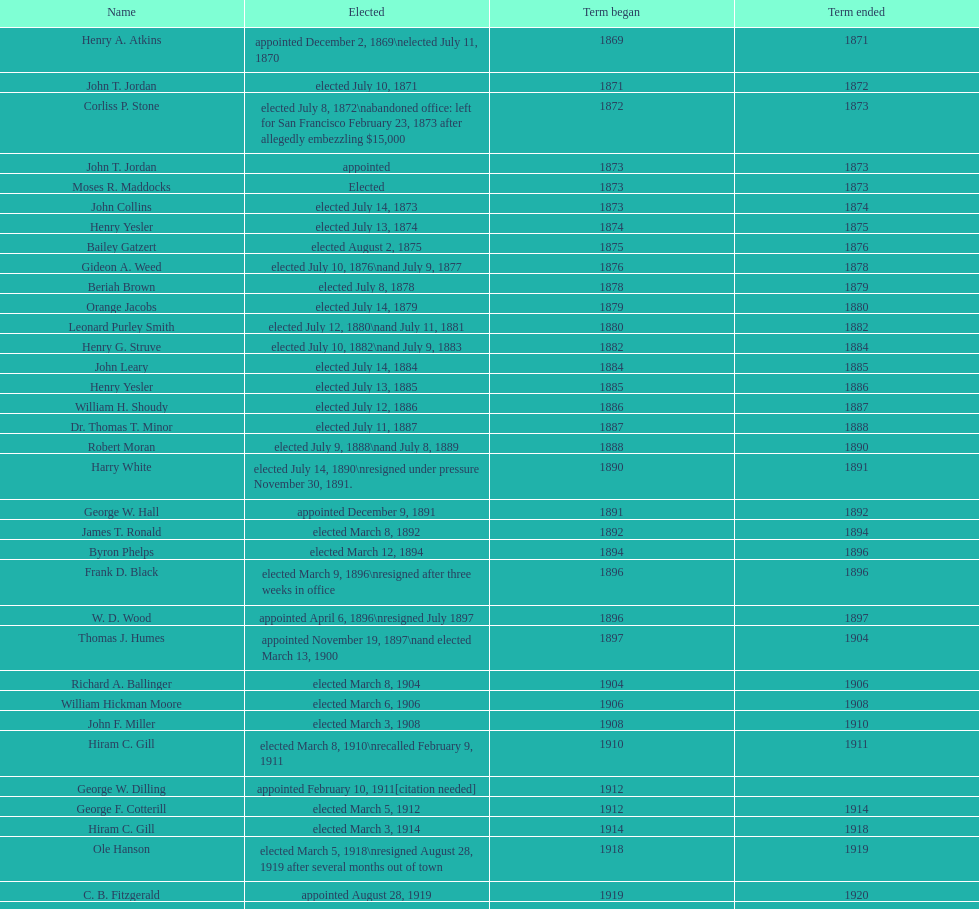Give me the full table as a dictionary. {'header': ['Name', 'Elected', 'Term began', 'Term ended'], 'rows': [['Henry A. Atkins', 'appointed December 2, 1869\\nelected July 11, 1870', '1869', '1871'], ['John T. Jordan', 'elected July 10, 1871', '1871', '1872'], ['Corliss P. Stone', 'elected July 8, 1872\\nabandoned office: left for San Francisco February 23, 1873 after allegedly embezzling $15,000', '1872', '1873'], ['John T. Jordan', 'appointed', '1873', '1873'], ['Moses R. Maddocks', 'Elected', '1873', '1873'], ['John Collins', 'elected July 14, 1873', '1873', '1874'], ['Henry Yesler', 'elected July 13, 1874', '1874', '1875'], ['Bailey Gatzert', 'elected August 2, 1875', '1875', '1876'], ['Gideon A. Weed', 'elected July 10, 1876\\nand July 9, 1877', '1876', '1878'], ['Beriah Brown', 'elected July 8, 1878', '1878', '1879'], ['Orange Jacobs', 'elected July 14, 1879', '1879', '1880'], ['Leonard Purley Smith', 'elected July 12, 1880\\nand July 11, 1881', '1880', '1882'], ['Henry G. Struve', 'elected July 10, 1882\\nand July 9, 1883', '1882', '1884'], ['John Leary', 'elected July 14, 1884', '1884', '1885'], ['Henry Yesler', 'elected July 13, 1885', '1885', '1886'], ['William H. Shoudy', 'elected July 12, 1886', '1886', '1887'], ['Dr. Thomas T. Minor', 'elected July 11, 1887', '1887', '1888'], ['Robert Moran', 'elected July 9, 1888\\nand July 8, 1889', '1888', '1890'], ['Harry White', 'elected July 14, 1890\\nresigned under pressure November 30, 1891.', '1890', '1891'], ['George W. Hall', 'appointed December 9, 1891', '1891', '1892'], ['James T. Ronald', 'elected March 8, 1892', '1892', '1894'], ['Byron Phelps', 'elected March 12, 1894', '1894', '1896'], ['Frank D. Black', 'elected March 9, 1896\\nresigned after three weeks in office', '1896', '1896'], ['W. D. Wood', 'appointed April 6, 1896\\nresigned July 1897', '1896', '1897'], ['Thomas J. Humes', 'appointed November 19, 1897\\nand elected March 13, 1900', '1897', '1904'], ['Richard A. Ballinger', 'elected March 8, 1904', '1904', '1906'], ['William Hickman Moore', 'elected March 6, 1906', '1906', '1908'], ['John F. Miller', 'elected March 3, 1908', '1908', '1910'], ['Hiram C. Gill', 'elected March 8, 1910\\nrecalled February 9, 1911', '1910', '1911'], ['George W. Dilling', 'appointed February 10, 1911[citation needed]', '1912', ''], ['George F. Cotterill', 'elected March 5, 1912', '1912', '1914'], ['Hiram C. Gill', 'elected March 3, 1914', '1914', '1918'], ['Ole Hanson', 'elected March 5, 1918\\nresigned August 28, 1919 after several months out of town', '1918', '1919'], ['C. B. Fitzgerald', 'appointed August 28, 1919', '1919', '1920'], ['Hugh M. Caldwell', 'elected March 2, 1920', '1920', '1922'], ['Edwin J. Brown', 'elected May 2, 1922\\nand March 4, 1924', '1922', '1926'], ['Bertha Knight Landes', 'elected March 9, 1926', '1926', '1928'], ['Frank E. Edwards', 'elected March 6, 1928\\nand March 4, 1930\\nrecalled July 13, 1931', '1928', '1931'], ['Robert H. Harlin', 'appointed July 14, 1931', '1931', '1932'], ['John F. Dore', 'elected March 8, 1932', '1932', '1934'], ['Charles L. Smith', 'elected March 6, 1934', '1934', '1936'], ['John F. Dore', 'elected March 3, 1936\\nbecame gravely ill and was relieved of office April 13, 1938, already a lame duck after the 1938 election. He died five days later.', '1936', '1938'], ['Arthur B. Langlie', "elected March 8, 1938\\nappointed to take office early, April 27, 1938, after Dore's death.\\nelected March 5, 1940\\nresigned January 11, 1941, to become Governor of Washington", '1938', '1941'], ['John E. Carroll', 'appointed January 27, 1941', '1941', '1941'], ['Earl Millikin', 'elected March 4, 1941', '1941', '1942'], ['William F. Devin', 'elected March 3, 1942, March 7, 1944, March 5, 1946, and March 2, 1948', '1942', '1952'], ['Allan Pomeroy', 'elected March 4, 1952', '1952', '1956'], ['Gordon S. Clinton', 'elected March 6, 1956\\nand March 8, 1960', '1956', '1964'], ["James d'Orma Braman", 'elected March 10, 1964\\nresigned March 23, 1969, to accept an appointment as an Assistant Secretary in the Department of Transportation in the Nixon administration.', '1964', '1969'], ['Floyd C. Miller', 'appointed March 23, 1969', '1969', '1969'], ['Wesley C. Uhlman', 'elected November 4, 1969\\nand November 6, 1973\\nsurvived recall attempt on July 1, 1975', 'December 1, 1969', 'January 1, 1978'], ['Charles Royer', 'elected November 8, 1977, November 3, 1981, and November 5, 1985', 'January 1, 1978', 'January 1, 1990'], ['Norman B. Rice', 'elected November 7, 1989', 'January 1, 1990', 'January 1, 1998'], ['Paul Schell', 'elected November 4, 1997', 'January 1, 1998', 'January 1, 2002'], ['Gregory J. Nickels', 'elected November 6, 2001\\nand November 8, 2005', 'January 1, 2002', 'January 1, 2010'], ['Michael McGinn', 'elected November 3, 2009', 'January 1, 2010', 'January 1, 2014'], ['Ed Murray', 'elected November 5, 2013', 'January 1, 2014', 'present']]} What is the number of mayors with the first name of john? 6. 